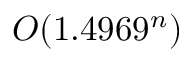<formula> <loc_0><loc_0><loc_500><loc_500>O ( 1 . 4 9 6 9 ^ { n } )</formula> 